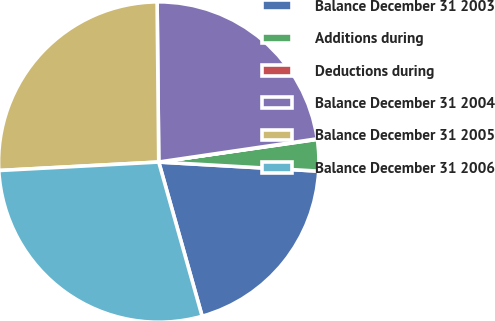<chart> <loc_0><loc_0><loc_500><loc_500><pie_chart><fcel>Balance December 31 2003<fcel>Additions during<fcel>Deductions during<fcel>Balance December 31 2004<fcel>Balance December 31 2005<fcel>Balance December 31 2006<nl><fcel>19.73%<fcel>3.17%<fcel>0.05%<fcel>22.85%<fcel>25.68%<fcel>28.52%<nl></chart> 